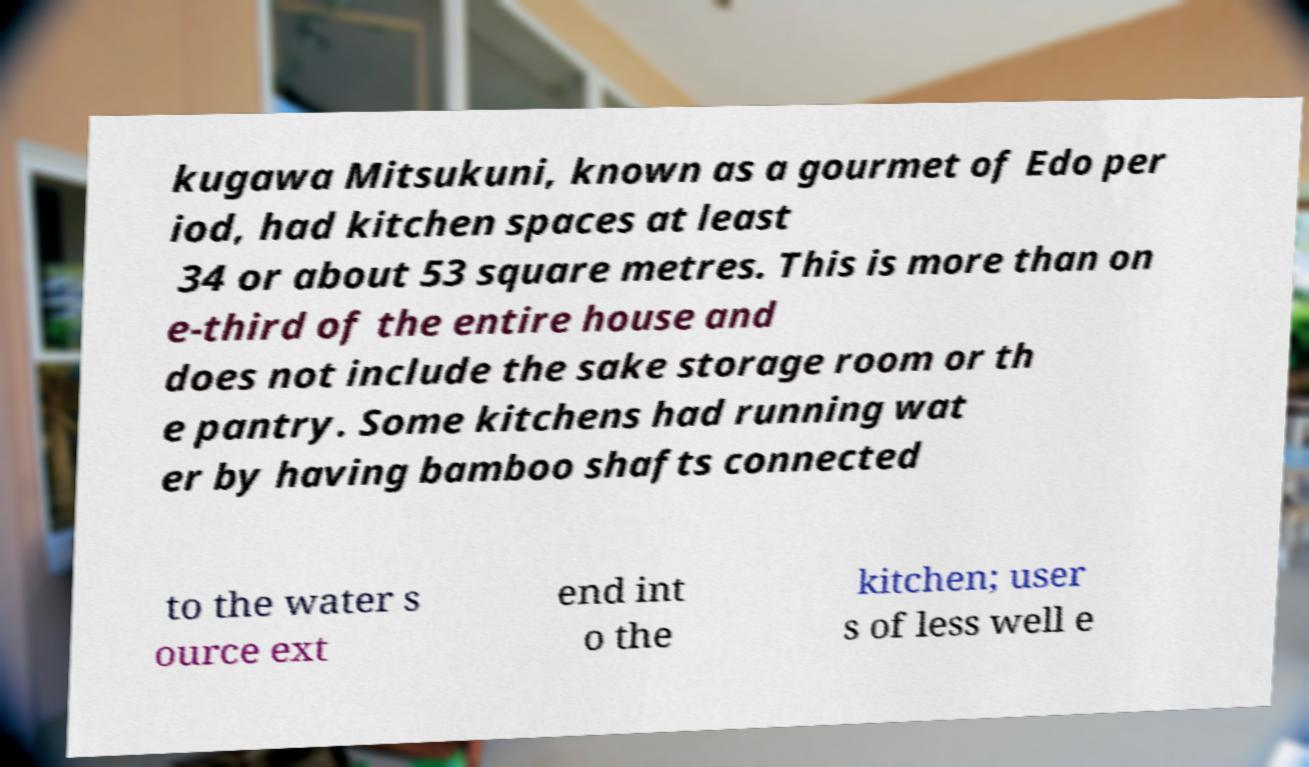Can you read and provide the text displayed in the image?This photo seems to have some interesting text. Can you extract and type it out for me? kugawa Mitsukuni, known as a gourmet of Edo per iod, had kitchen spaces at least 34 or about 53 square metres. This is more than on e-third of the entire house and does not include the sake storage room or th e pantry. Some kitchens had running wat er by having bamboo shafts connected to the water s ource ext end int o the kitchen; user s of less well e 